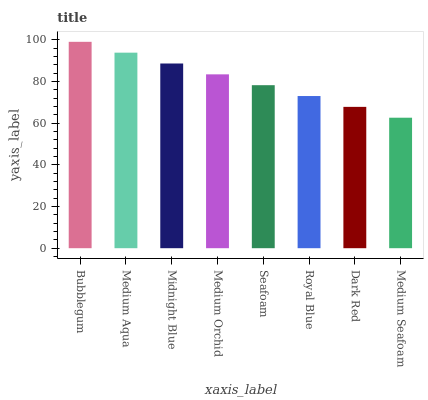Is Medium Seafoam the minimum?
Answer yes or no. Yes. Is Bubblegum the maximum?
Answer yes or no. Yes. Is Medium Aqua the minimum?
Answer yes or no. No. Is Medium Aqua the maximum?
Answer yes or no. No. Is Bubblegum greater than Medium Aqua?
Answer yes or no. Yes. Is Medium Aqua less than Bubblegum?
Answer yes or no. Yes. Is Medium Aqua greater than Bubblegum?
Answer yes or no. No. Is Bubblegum less than Medium Aqua?
Answer yes or no. No. Is Medium Orchid the high median?
Answer yes or no. Yes. Is Seafoam the low median?
Answer yes or no. Yes. Is Bubblegum the high median?
Answer yes or no. No. Is Medium Aqua the low median?
Answer yes or no. No. 